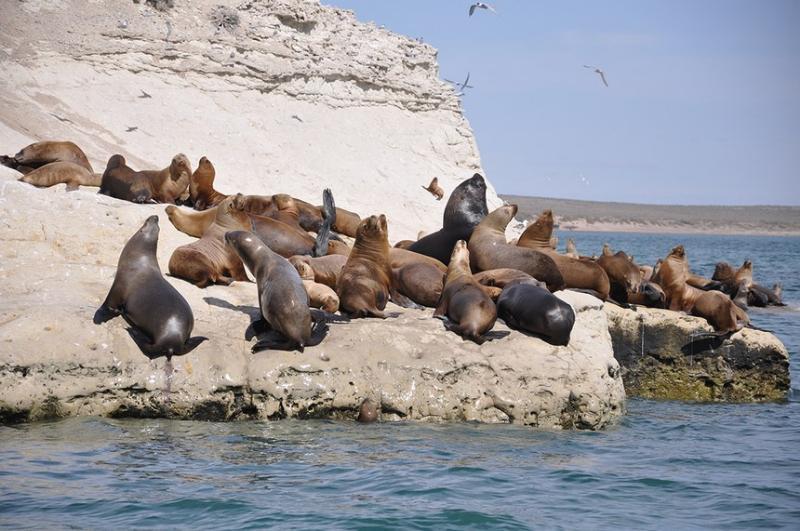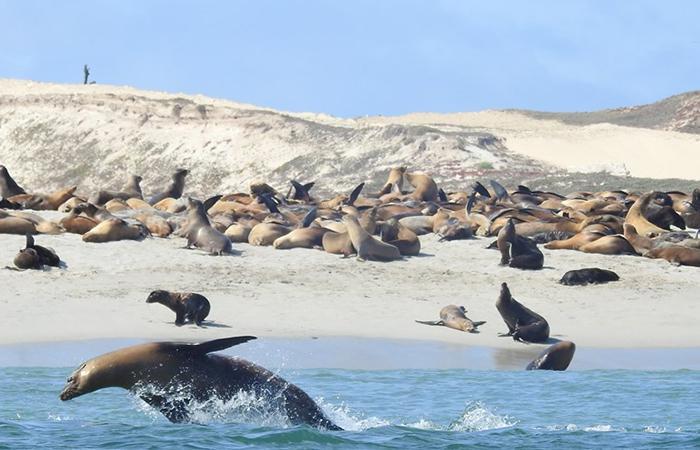The first image is the image on the left, the second image is the image on the right. For the images displayed, is the sentence "Waves are coming onto the beach." factually correct? Answer yes or no. Yes. The first image is the image on the left, the second image is the image on the right. Assess this claim about the two images: "Each image shows a mass of at least 15 seals on a natural elevated surface with water visible next to it.". Correct or not? Answer yes or no. Yes. 